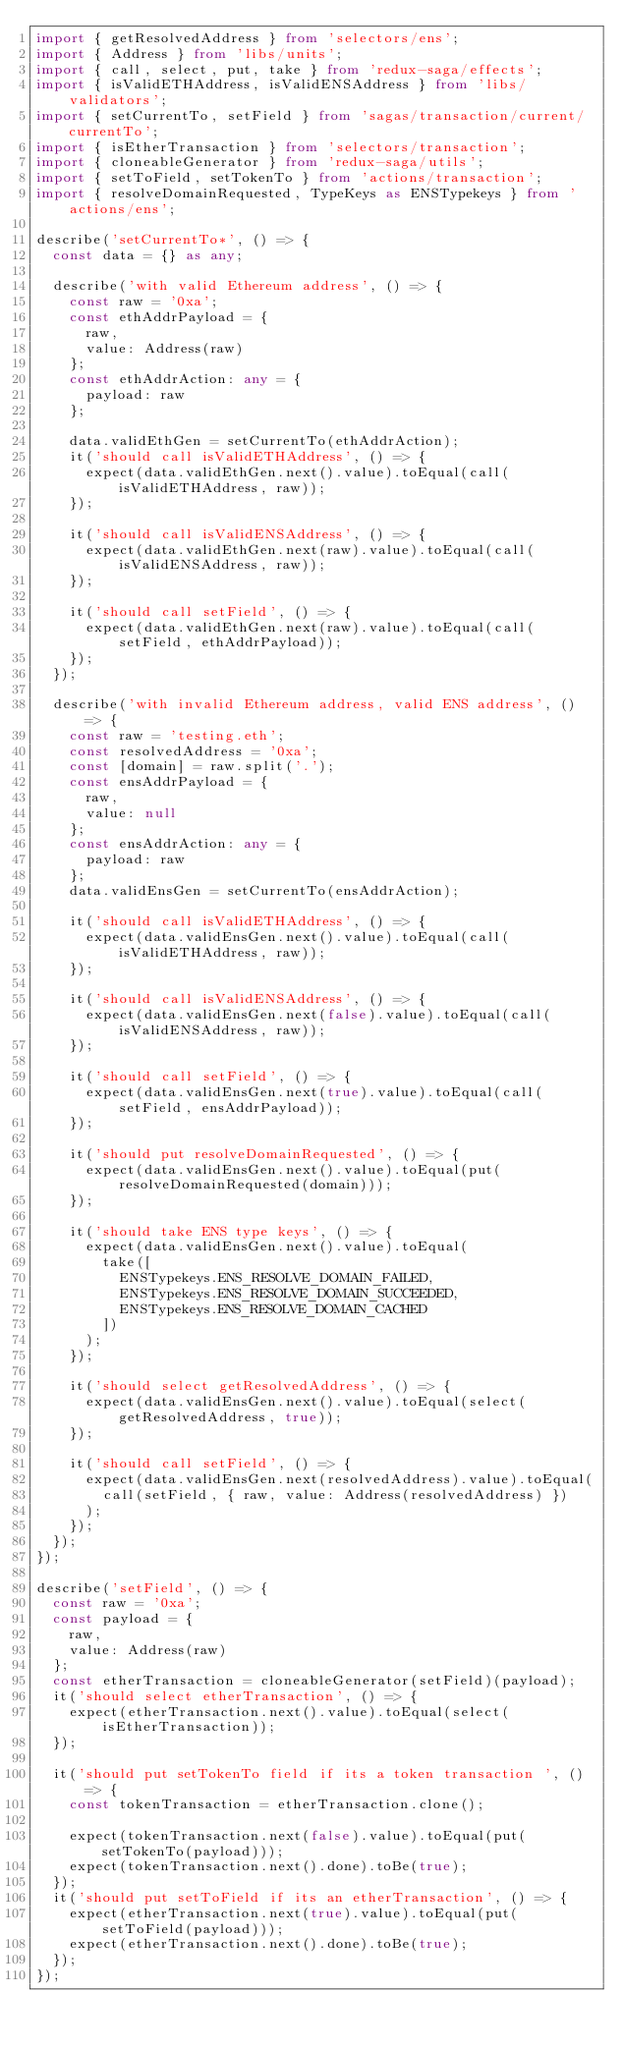<code> <loc_0><loc_0><loc_500><loc_500><_TypeScript_>import { getResolvedAddress } from 'selectors/ens';
import { Address } from 'libs/units';
import { call, select, put, take } from 'redux-saga/effects';
import { isValidETHAddress, isValidENSAddress } from 'libs/validators';
import { setCurrentTo, setField } from 'sagas/transaction/current/currentTo';
import { isEtherTransaction } from 'selectors/transaction';
import { cloneableGenerator } from 'redux-saga/utils';
import { setToField, setTokenTo } from 'actions/transaction';
import { resolveDomainRequested, TypeKeys as ENSTypekeys } from 'actions/ens';

describe('setCurrentTo*', () => {
  const data = {} as any;

  describe('with valid Ethereum address', () => {
    const raw = '0xa';
    const ethAddrPayload = {
      raw,
      value: Address(raw)
    };
    const ethAddrAction: any = {
      payload: raw
    };

    data.validEthGen = setCurrentTo(ethAddrAction);
    it('should call isValidETHAddress', () => {
      expect(data.validEthGen.next().value).toEqual(call(isValidETHAddress, raw));
    });

    it('should call isValidENSAddress', () => {
      expect(data.validEthGen.next(raw).value).toEqual(call(isValidENSAddress, raw));
    });

    it('should call setField', () => {
      expect(data.validEthGen.next(raw).value).toEqual(call(setField, ethAddrPayload));
    });
  });

  describe('with invalid Ethereum address, valid ENS address', () => {
    const raw = 'testing.eth';
    const resolvedAddress = '0xa';
    const [domain] = raw.split('.');
    const ensAddrPayload = {
      raw,
      value: null
    };
    const ensAddrAction: any = {
      payload: raw
    };
    data.validEnsGen = setCurrentTo(ensAddrAction);

    it('should call isValidETHAddress', () => {
      expect(data.validEnsGen.next().value).toEqual(call(isValidETHAddress, raw));
    });

    it('should call isValidENSAddress', () => {
      expect(data.validEnsGen.next(false).value).toEqual(call(isValidENSAddress, raw));
    });

    it('should call setField', () => {
      expect(data.validEnsGen.next(true).value).toEqual(call(setField, ensAddrPayload));
    });

    it('should put resolveDomainRequested', () => {
      expect(data.validEnsGen.next().value).toEqual(put(resolveDomainRequested(domain)));
    });

    it('should take ENS type keys', () => {
      expect(data.validEnsGen.next().value).toEqual(
        take([
          ENSTypekeys.ENS_RESOLVE_DOMAIN_FAILED,
          ENSTypekeys.ENS_RESOLVE_DOMAIN_SUCCEEDED,
          ENSTypekeys.ENS_RESOLVE_DOMAIN_CACHED
        ])
      );
    });

    it('should select getResolvedAddress', () => {
      expect(data.validEnsGen.next().value).toEqual(select(getResolvedAddress, true));
    });

    it('should call setField', () => {
      expect(data.validEnsGen.next(resolvedAddress).value).toEqual(
        call(setField, { raw, value: Address(resolvedAddress) })
      );
    });
  });
});

describe('setField', () => {
  const raw = '0xa';
  const payload = {
    raw,
    value: Address(raw)
  };
  const etherTransaction = cloneableGenerator(setField)(payload);
  it('should select etherTransaction', () => {
    expect(etherTransaction.next().value).toEqual(select(isEtherTransaction));
  });

  it('should put setTokenTo field if its a token transaction ', () => {
    const tokenTransaction = etherTransaction.clone();

    expect(tokenTransaction.next(false).value).toEqual(put(setTokenTo(payload)));
    expect(tokenTransaction.next().done).toBe(true);
  });
  it('should put setToField if its an etherTransaction', () => {
    expect(etherTransaction.next(true).value).toEqual(put(setToField(payload)));
    expect(etherTransaction.next().done).toBe(true);
  });
});
</code> 